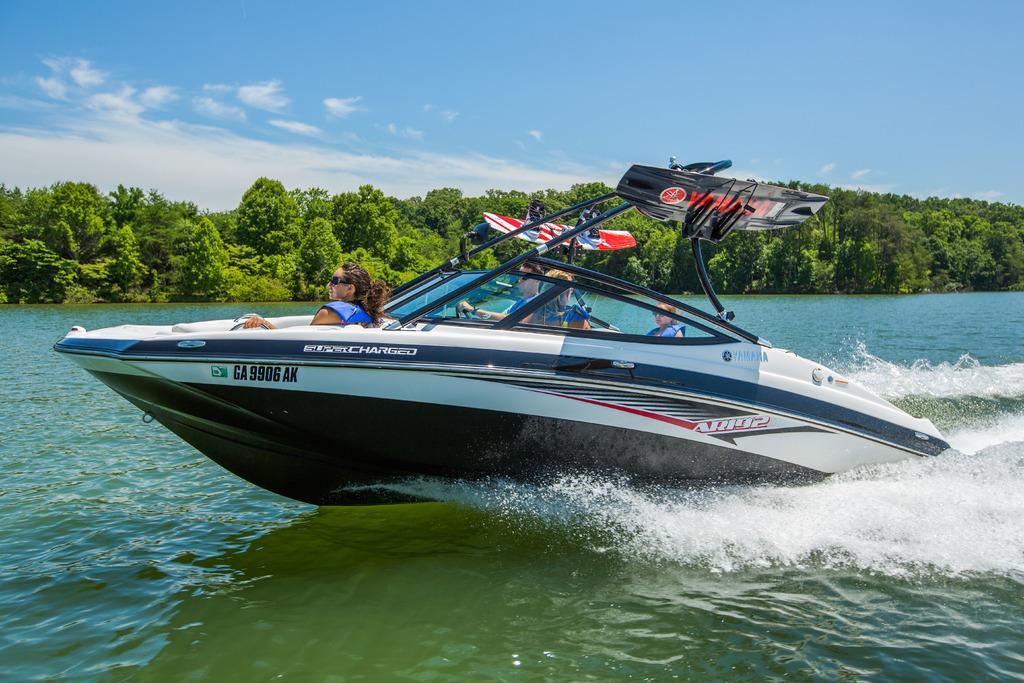How would you summarize this image in a sentence or two? In this image I can see four persons on a boat. There is water, there are trees and in the background there is sky. 